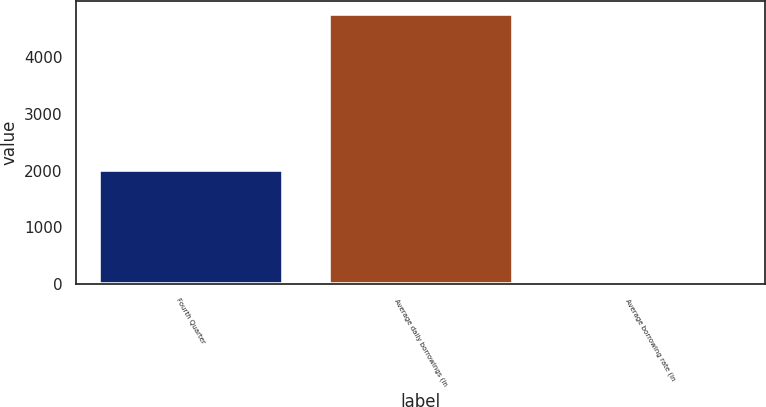<chart> <loc_0><loc_0><loc_500><loc_500><bar_chart><fcel>Fourth Quarter<fcel>Average daily borrowings (in<fcel>Average borrowing rate (in<nl><fcel>2014<fcel>4750<fcel>6.6<nl></chart> 